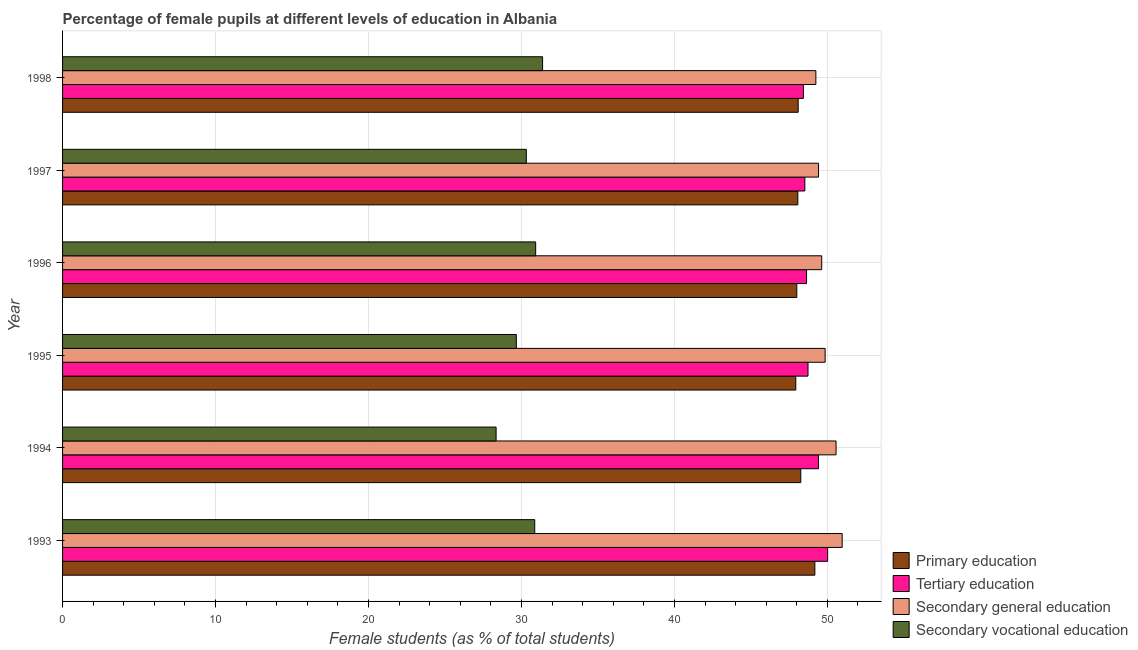How many bars are there on the 4th tick from the bottom?
Offer a terse response. 4. What is the percentage of female students in secondary vocational education in 1996?
Offer a terse response. 30.93. Across all years, what is the maximum percentage of female students in secondary education?
Offer a very short reply. 50.97. Across all years, what is the minimum percentage of female students in secondary education?
Make the answer very short. 49.25. In which year was the percentage of female students in primary education minimum?
Offer a very short reply. 1995. What is the total percentage of female students in tertiary education in the graph?
Provide a short and direct response. 293.76. What is the difference between the percentage of female students in tertiary education in 1993 and that in 1994?
Ensure brevity in your answer.  0.6. What is the difference between the percentage of female students in secondary vocational education in 1997 and the percentage of female students in tertiary education in 1995?
Your answer should be compact. -18.42. What is the average percentage of female students in primary education per year?
Your response must be concise. 48.26. In the year 1995, what is the difference between the percentage of female students in primary education and percentage of female students in secondary education?
Keep it short and to the point. -1.92. What is the ratio of the percentage of female students in secondary vocational education in 1994 to that in 1998?
Offer a terse response. 0.9. Is the difference between the percentage of female students in secondary education in 1993 and 1997 greater than the difference between the percentage of female students in secondary vocational education in 1993 and 1997?
Your answer should be compact. Yes. What is the difference between the highest and the second highest percentage of female students in tertiary education?
Offer a terse response. 0.6. What is the difference between the highest and the lowest percentage of female students in secondary vocational education?
Your answer should be very brief. 3.04. What does the 2nd bar from the top in 1998 represents?
Offer a very short reply. Secondary general education. What does the 4th bar from the bottom in 1997 represents?
Your answer should be compact. Secondary vocational education. Are all the bars in the graph horizontal?
Provide a succinct answer. Yes. How many years are there in the graph?
Keep it short and to the point. 6. Where does the legend appear in the graph?
Offer a terse response. Bottom right. How are the legend labels stacked?
Make the answer very short. Vertical. What is the title of the graph?
Offer a very short reply. Percentage of female pupils at different levels of education in Albania. Does "Taxes on goods and services" appear as one of the legend labels in the graph?
Your response must be concise. No. What is the label or title of the X-axis?
Keep it short and to the point. Female students (as % of total students). What is the Female students (as % of total students) in Primary education in 1993?
Provide a short and direct response. 49.18. What is the Female students (as % of total students) of Tertiary education in 1993?
Offer a very short reply. 50.02. What is the Female students (as % of total students) of Secondary general education in 1993?
Provide a short and direct response. 50.97. What is the Female students (as % of total students) in Secondary vocational education in 1993?
Offer a very short reply. 30.87. What is the Female students (as % of total students) in Primary education in 1994?
Keep it short and to the point. 48.26. What is the Female students (as % of total students) in Tertiary education in 1994?
Offer a terse response. 49.42. What is the Female students (as % of total students) in Secondary general education in 1994?
Make the answer very short. 50.57. What is the Female students (as % of total students) of Secondary vocational education in 1994?
Your response must be concise. 28.34. What is the Female students (as % of total students) of Primary education in 1995?
Provide a short and direct response. 47.93. What is the Female students (as % of total students) in Tertiary education in 1995?
Your response must be concise. 48.73. What is the Female students (as % of total students) of Secondary general education in 1995?
Your answer should be very brief. 49.85. What is the Female students (as % of total students) of Secondary vocational education in 1995?
Keep it short and to the point. 29.66. What is the Female students (as % of total students) of Primary education in 1996?
Your answer should be compact. 48. What is the Female students (as % of total students) in Tertiary education in 1996?
Offer a terse response. 48.64. What is the Female students (as % of total students) in Secondary general education in 1996?
Provide a short and direct response. 49.63. What is the Female students (as % of total students) in Secondary vocational education in 1996?
Your answer should be compact. 30.93. What is the Female students (as % of total students) in Primary education in 1997?
Give a very brief answer. 48.07. What is the Female students (as % of total students) of Tertiary education in 1997?
Offer a terse response. 48.53. What is the Female students (as % of total students) in Secondary general education in 1997?
Your answer should be compact. 49.42. What is the Female students (as % of total students) in Secondary vocational education in 1997?
Ensure brevity in your answer.  30.32. What is the Female students (as % of total students) in Primary education in 1998?
Provide a short and direct response. 48.09. What is the Female students (as % of total students) of Tertiary education in 1998?
Make the answer very short. 48.43. What is the Female students (as % of total students) in Secondary general education in 1998?
Your answer should be very brief. 49.25. What is the Female students (as % of total students) of Secondary vocational education in 1998?
Give a very brief answer. 31.38. Across all years, what is the maximum Female students (as % of total students) of Primary education?
Offer a very short reply. 49.18. Across all years, what is the maximum Female students (as % of total students) in Tertiary education?
Your response must be concise. 50.02. Across all years, what is the maximum Female students (as % of total students) in Secondary general education?
Make the answer very short. 50.97. Across all years, what is the maximum Female students (as % of total students) of Secondary vocational education?
Provide a succinct answer. 31.38. Across all years, what is the minimum Female students (as % of total students) in Primary education?
Make the answer very short. 47.93. Across all years, what is the minimum Female students (as % of total students) in Tertiary education?
Provide a succinct answer. 48.43. Across all years, what is the minimum Female students (as % of total students) in Secondary general education?
Your response must be concise. 49.25. Across all years, what is the minimum Female students (as % of total students) in Secondary vocational education?
Your answer should be very brief. 28.34. What is the total Female students (as % of total students) in Primary education in the graph?
Ensure brevity in your answer.  289.53. What is the total Female students (as % of total students) in Tertiary education in the graph?
Give a very brief answer. 293.76. What is the total Female students (as % of total students) of Secondary general education in the graph?
Make the answer very short. 299.68. What is the total Female students (as % of total students) in Secondary vocational education in the graph?
Your answer should be very brief. 181.5. What is the difference between the Female students (as % of total students) of Primary education in 1993 and that in 1994?
Your answer should be compact. 0.92. What is the difference between the Female students (as % of total students) in Tertiary education in 1993 and that in 1994?
Provide a short and direct response. 0.6. What is the difference between the Female students (as % of total students) in Secondary general education in 1993 and that in 1994?
Make the answer very short. 0.4. What is the difference between the Female students (as % of total students) in Secondary vocational education in 1993 and that in 1994?
Offer a terse response. 2.53. What is the difference between the Female students (as % of total students) in Primary education in 1993 and that in 1995?
Your answer should be compact. 1.25. What is the difference between the Female students (as % of total students) in Tertiary education in 1993 and that in 1995?
Your answer should be very brief. 1.28. What is the difference between the Female students (as % of total students) of Secondary general education in 1993 and that in 1995?
Provide a short and direct response. 1.11. What is the difference between the Female students (as % of total students) in Secondary vocational education in 1993 and that in 1995?
Offer a terse response. 1.2. What is the difference between the Female students (as % of total students) in Primary education in 1993 and that in 1996?
Provide a short and direct response. 1.18. What is the difference between the Female students (as % of total students) of Tertiary education in 1993 and that in 1996?
Offer a terse response. 1.38. What is the difference between the Female students (as % of total students) of Secondary general education in 1993 and that in 1996?
Your answer should be compact. 1.34. What is the difference between the Female students (as % of total students) of Secondary vocational education in 1993 and that in 1996?
Ensure brevity in your answer.  -0.06. What is the difference between the Female students (as % of total students) of Primary education in 1993 and that in 1997?
Give a very brief answer. 1.11. What is the difference between the Female students (as % of total students) in Tertiary education in 1993 and that in 1997?
Your answer should be compact. 1.49. What is the difference between the Female students (as % of total students) in Secondary general education in 1993 and that in 1997?
Provide a short and direct response. 1.54. What is the difference between the Female students (as % of total students) of Secondary vocational education in 1993 and that in 1997?
Your answer should be compact. 0.55. What is the difference between the Female students (as % of total students) in Primary education in 1993 and that in 1998?
Your response must be concise. 1.09. What is the difference between the Female students (as % of total students) of Tertiary education in 1993 and that in 1998?
Make the answer very short. 1.59. What is the difference between the Female students (as % of total students) of Secondary general education in 1993 and that in 1998?
Provide a short and direct response. 1.72. What is the difference between the Female students (as % of total students) in Secondary vocational education in 1993 and that in 1998?
Your response must be concise. -0.51. What is the difference between the Female students (as % of total students) of Primary education in 1994 and that in 1995?
Keep it short and to the point. 0.33. What is the difference between the Female students (as % of total students) of Tertiary education in 1994 and that in 1995?
Provide a short and direct response. 0.68. What is the difference between the Female students (as % of total students) in Secondary general education in 1994 and that in 1995?
Provide a succinct answer. 0.71. What is the difference between the Female students (as % of total students) of Secondary vocational education in 1994 and that in 1995?
Make the answer very short. -1.32. What is the difference between the Female students (as % of total students) of Primary education in 1994 and that in 1996?
Keep it short and to the point. 0.26. What is the difference between the Female students (as % of total students) of Tertiary education in 1994 and that in 1996?
Offer a terse response. 0.78. What is the difference between the Female students (as % of total students) of Secondary general education in 1994 and that in 1996?
Provide a short and direct response. 0.94. What is the difference between the Female students (as % of total students) of Secondary vocational education in 1994 and that in 1996?
Your response must be concise. -2.59. What is the difference between the Female students (as % of total students) in Primary education in 1994 and that in 1997?
Ensure brevity in your answer.  0.19. What is the difference between the Female students (as % of total students) in Tertiary education in 1994 and that in 1997?
Provide a short and direct response. 0.89. What is the difference between the Female students (as % of total students) in Secondary general education in 1994 and that in 1997?
Ensure brevity in your answer.  1.15. What is the difference between the Female students (as % of total students) of Secondary vocational education in 1994 and that in 1997?
Offer a very short reply. -1.97. What is the difference between the Female students (as % of total students) of Primary education in 1994 and that in 1998?
Your answer should be compact. 0.17. What is the difference between the Female students (as % of total students) of Secondary general education in 1994 and that in 1998?
Your response must be concise. 1.32. What is the difference between the Female students (as % of total students) in Secondary vocational education in 1994 and that in 1998?
Offer a terse response. -3.04. What is the difference between the Female students (as % of total students) of Primary education in 1995 and that in 1996?
Offer a terse response. -0.07. What is the difference between the Female students (as % of total students) in Tertiary education in 1995 and that in 1996?
Your answer should be very brief. 0.1. What is the difference between the Female students (as % of total students) in Secondary general education in 1995 and that in 1996?
Provide a short and direct response. 0.22. What is the difference between the Female students (as % of total students) in Secondary vocational education in 1995 and that in 1996?
Provide a short and direct response. -1.27. What is the difference between the Female students (as % of total students) of Primary education in 1995 and that in 1997?
Keep it short and to the point. -0.13. What is the difference between the Female students (as % of total students) of Tertiary education in 1995 and that in 1997?
Provide a short and direct response. 0.21. What is the difference between the Female students (as % of total students) of Secondary general education in 1995 and that in 1997?
Offer a very short reply. 0.43. What is the difference between the Female students (as % of total students) in Secondary vocational education in 1995 and that in 1997?
Offer a very short reply. -0.65. What is the difference between the Female students (as % of total students) of Primary education in 1995 and that in 1998?
Offer a very short reply. -0.16. What is the difference between the Female students (as % of total students) in Tertiary education in 1995 and that in 1998?
Give a very brief answer. 0.3. What is the difference between the Female students (as % of total students) in Secondary general education in 1995 and that in 1998?
Keep it short and to the point. 0.61. What is the difference between the Female students (as % of total students) in Secondary vocational education in 1995 and that in 1998?
Your answer should be compact. -1.72. What is the difference between the Female students (as % of total students) in Primary education in 1996 and that in 1997?
Make the answer very short. -0.07. What is the difference between the Female students (as % of total students) of Tertiary education in 1996 and that in 1997?
Your answer should be compact. 0.11. What is the difference between the Female students (as % of total students) in Secondary general education in 1996 and that in 1997?
Provide a short and direct response. 0.21. What is the difference between the Female students (as % of total students) of Secondary vocational education in 1996 and that in 1997?
Make the answer very short. 0.61. What is the difference between the Female students (as % of total students) of Primary education in 1996 and that in 1998?
Your answer should be very brief. -0.09. What is the difference between the Female students (as % of total students) of Tertiary education in 1996 and that in 1998?
Provide a short and direct response. 0.21. What is the difference between the Female students (as % of total students) in Secondary general education in 1996 and that in 1998?
Make the answer very short. 0.38. What is the difference between the Female students (as % of total students) of Secondary vocational education in 1996 and that in 1998?
Your answer should be compact. -0.45. What is the difference between the Female students (as % of total students) in Primary education in 1997 and that in 1998?
Your answer should be compact. -0.02. What is the difference between the Female students (as % of total students) in Tertiary education in 1997 and that in 1998?
Offer a terse response. 0.1. What is the difference between the Female students (as % of total students) in Secondary general education in 1997 and that in 1998?
Ensure brevity in your answer.  0.18. What is the difference between the Female students (as % of total students) of Secondary vocational education in 1997 and that in 1998?
Offer a very short reply. -1.06. What is the difference between the Female students (as % of total students) of Primary education in 1993 and the Female students (as % of total students) of Tertiary education in 1994?
Offer a very short reply. -0.23. What is the difference between the Female students (as % of total students) in Primary education in 1993 and the Female students (as % of total students) in Secondary general education in 1994?
Give a very brief answer. -1.39. What is the difference between the Female students (as % of total students) of Primary education in 1993 and the Female students (as % of total students) of Secondary vocational education in 1994?
Provide a succinct answer. 20.84. What is the difference between the Female students (as % of total students) in Tertiary education in 1993 and the Female students (as % of total students) in Secondary general education in 1994?
Provide a short and direct response. -0.55. What is the difference between the Female students (as % of total students) in Tertiary education in 1993 and the Female students (as % of total students) in Secondary vocational education in 1994?
Give a very brief answer. 21.67. What is the difference between the Female students (as % of total students) in Secondary general education in 1993 and the Female students (as % of total students) in Secondary vocational education in 1994?
Your response must be concise. 22.62. What is the difference between the Female students (as % of total students) in Primary education in 1993 and the Female students (as % of total students) in Tertiary education in 1995?
Provide a short and direct response. 0.45. What is the difference between the Female students (as % of total students) of Primary education in 1993 and the Female students (as % of total students) of Secondary general education in 1995?
Give a very brief answer. -0.67. What is the difference between the Female students (as % of total students) in Primary education in 1993 and the Female students (as % of total students) in Secondary vocational education in 1995?
Your answer should be compact. 19.52. What is the difference between the Female students (as % of total students) of Tertiary education in 1993 and the Female students (as % of total students) of Secondary general education in 1995?
Offer a very short reply. 0.16. What is the difference between the Female students (as % of total students) of Tertiary education in 1993 and the Female students (as % of total students) of Secondary vocational education in 1995?
Give a very brief answer. 20.35. What is the difference between the Female students (as % of total students) of Secondary general education in 1993 and the Female students (as % of total students) of Secondary vocational education in 1995?
Your answer should be very brief. 21.3. What is the difference between the Female students (as % of total students) of Primary education in 1993 and the Female students (as % of total students) of Tertiary education in 1996?
Make the answer very short. 0.54. What is the difference between the Female students (as % of total students) of Primary education in 1993 and the Female students (as % of total students) of Secondary general education in 1996?
Offer a very short reply. -0.45. What is the difference between the Female students (as % of total students) in Primary education in 1993 and the Female students (as % of total students) in Secondary vocational education in 1996?
Offer a terse response. 18.25. What is the difference between the Female students (as % of total students) in Tertiary education in 1993 and the Female students (as % of total students) in Secondary general education in 1996?
Keep it short and to the point. 0.39. What is the difference between the Female students (as % of total students) of Tertiary education in 1993 and the Female students (as % of total students) of Secondary vocational education in 1996?
Make the answer very short. 19.09. What is the difference between the Female students (as % of total students) of Secondary general education in 1993 and the Female students (as % of total students) of Secondary vocational education in 1996?
Your response must be concise. 20.04. What is the difference between the Female students (as % of total students) in Primary education in 1993 and the Female students (as % of total students) in Tertiary education in 1997?
Provide a succinct answer. 0.65. What is the difference between the Female students (as % of total students) of Primary education in 1993 and the Female students (as % of total students) of Secondary general education in 1997?
Offer a terse response. -0.24. What is the difference between the Female students (as % of total students) of Primary education in 1993 and the Female students (as % of total students) of Secondary vocational education in 1997?
Your answer should be compact. 18.86. What is the difference between the Female students (as % of total students) of Tertiary education in 1993 and the Female students (as % of total students) of Secondary general education in 1997?
Make the answer very short. 0.59. What is the difference between the Female students (as % of total students) in Tertiary education in 1993 and the Female students (as % of total students) in Secondary vocational education in 1997?
Provide a short and direct response. 19.7. What is the difference between the Female students (as % of total students) of Secondary general education in 1993 and the Female students (as % of total students) of Secondary vocational education in 1997?
Your response must be concise. 20.65. What is the difference between the Female students (as % of total students) of Primary education in 1993 and the Female students (as % of total students) of Tertiary education in 1998?
Your response must be concise. 0.75. What is the difference between the Female students (as % of total students) in Primary education in 1993 and the Female students (as % of total students) in Secondary general education in 1998?
Your answer should be compact. -0.06. What is the difference between the Female students (as % of total students) in Primary education in 1993 and the Female students (as % of total students) in Secondary vocational education in 1998?
Give a very brief answer. 17.8. What is the difference between the Female students (as % of total students) in Tertiary education in 1993 and the Female students (as % of total students) in Secondary general education in 1998?
Offer a very short reply. 0.77. What is the difference between the Female students (as % of total students) in Tertiary education in 1993 and the Female students (as % of total students) in Secondary vocational education in 1998?
Provide a succinct answer. 18.63. What is the difference between the Female students (as % of total students) in Secondary general education in 1993 and the Female students (as % of total students) in Secondary vocational education in 1998?
Give a very brief answer. 19.58. What is the difference between the Female students (as % of total students) of Primary education in 1994 and the Female students (as % of total students) of Tertiary education in 1995?
Ensure brevity in your answer.  -0.47. What is the difference between the Female students (as % of total students) in Primary education in 1994 and the Female students (as % of total students) in Secondary general education in 1995?
Your answer should be very brief. -1.59. What is the difference between the Female students (as % of total students) in Primary education in 1994 and the Female students (as % of total students) in Secondary vocational education in 1995?
Keep it short and to the point. 18.6. What is the difference between the Female students (as % of total students) in Tertiary education in 1994 and the Female students (as % of total students) in Secondary general education in 1995?
Your answer should be compact. -0.44. What is the difference between the Female students (as % of total students) of Tertiary education in 1994 and the Female students (as % of total students) of Secondary vocational education in 1995?
Your answer should be compact. 19.75. What is the difference between the Female students (as % of total students) in Secondary general education in 1994 and the Female students (as % of total students) in Secondary vocational education in 1995?
Your answer should be very brief. 20.9. What is the difference between the Female students (as % of total students) in Primary education in 1994 and the Female students (as % of total students) in Tertiary education in 1996?
Provide a short and direct response. -0.38. What is the difference between the Female students (as % of total students) in Primary education in 1994 and the Female students (as % of total students) in Secondary general education in 1996?
Provide a succinct answer. -1.37. What is the difference between the Female students (as % of total students) in Primary education in 1994 and the Female students (as % of total students) in Secondary vocational education in 1996?
Offer a terse response. 17.33. What is the difference between the Female students (as % of total students) in Tertiary education in 1994 and the Female students (as % of total students) in Secondary general education in 1996?
Give a very brief answer. -0.21. What is the difference between the Female students (as % of total students) of Tertiary education in 1994 and the Female students (as % of total students) of Secondary vocational education in 1996?
Your answer should be compact. 18.49. What is the difference between the Female students (as % of total students) in Secondary general education in 1994 and the Female students (as % of total students) in Secondary vocational education in 1996?
Your response must be concise. 19.64. What is the difference between the Female students (as % of total students) in Primary education in 1994 and the Female students (as % of total students) in Tertiary education in 1997?
Offer a terse response. -0.27. What is the difference between the Female students (as % of total students) of Primary education in 1994 and the Female students (as % of total students) of Secondary general education in 1997?
Ensure brevity in your answer.  -1.16. What is the difference between the Female students (as % of total students) in Primary education in 1994 and the Female students (as % of total students) in Secondary vocational education in 1997?
Give a very brief answer. 17.94. What is the difference between the Female students (as % of total students) in Tertiary education in 1994 and the Female students (as % of total students) in Secondary general education in 1997?
Make the answer very short. -0.01. What is the difference between the Female students (as % of total students) of Tertiary education in 1994 and the Female students (as % of total students) of Secondary vocational education in 1997?
Offer a terse response. 19.1. What is the difference between the Female students (as % of total students) in Secondary general education in 1994 and the Female students (as % of total students) in Secondary vocational education in 1997?
Provide a short and direct response. 20.25. What is the difference between the Female students (as % of total students) in Primary education in 1994 and the Female students (as % of total students) in Tertiary education in 1998?
Ensure brevity in your answer.  -0.17. What is the difference between the Female students (as % of total students) in Primary education in 1994 and the Female students (as % of total students) in Secondary general education in 1998?
Keep it short and to the point. -0.99. What is the difference between the Female students (as % of total students) in Primary education in 1994 and the Female students (as % of total students) in Secondary vocational education in 1998?
Offer a terse response. 16.88. What is the difference between the Female students (as % of total students) in Tertiary education in 1994 and the Female students (as % of total students) in Secondary general education in 1998?
Keep it short and to the point. 0.17. What is the difference between the Female students (as % of total students) in Tertiary education in 1994 and the Female students (as % of total students) in Secondary vocational education in 1998?
Your answer should be very brief. 18.03. What is the difference between the Female students (as % of total students) in Secondary general education in 1994 and the Female students (as % of total students) in Secondary vocational education in 1998?
Your answer should be compact. 19.19. What is the difference between the Female students (as % of total students) in Primary education in 1995 and the Female students (as % of total students) in Tertiary education in 1996?
Provide a succinct answer. -0.7. What is the difference between the Female students (as % of total students) of Primary education in 1995 and the Female students (as % of total students) of Secondary general education in 1996?
Ensure brevity in your answer.  -1.69. What is the difference between the Female students (as % of total students) in Primary education in 1995 and the Female students (as % of total students) in Secondary vocational education in 1996?
Give a very brief answer. 17. What is the difference between the Female students (as % of total students) in Tertiary education in 1995 and the Female students (as % of total students) in Secondary general education in 1996?
Your answer should be compact. -0.9. What is the difference between the Female students (as % of total students) in Tertiary education in 1995 and the Female students (as % of total students) in Secondary vocational education in 1996?
Give a very brief answer. 17.8. What is the difference between the Female students (as % of total students) of Secondary general education in 1995 and the Female students (as % of total students) of Secondary vocational education in 1996?
Ensure brevity in your answer.  18.92. What is the difference between the Female students (as % of total students) of Primary education in 1995 and the Female students (as % of total students) of Tertiary education in 1997?
Offer a very short reply. -0.59. What is the difference between the Female students (as % of total students) of Primary education in 1995 and the Female students (as % of total students) of Secondary general education in 1997?
Your answer should be compact. -1.49. What is the difference between the Female students (as % of total students) in Primary education in 1995 and the Female students (as % of total students) in Secondary vocational education in 1997?
Keep it short and to the point. 17.62. What is the difference between the Female students (as % of total students) in Tertiary education in 1995 and the Female students (as % of total students) in Secondary general education in 1997?
Provide a succinct answer. -0.69. What is the difference between the Female students (as % of total students) of Tertiary education in 1995 and the Female students (as % of total students) of Secondary vocational education in 1997?
Offer a very short reply. 18.42. What is the difference between the Female students (as % of total students) of Secondary general education in 1995 and the Female students (as % of total students) of Secondary vocational education in 1997?
Your answer should be very brief. 19.54. What is the difference between the Female students (as % of total students) in Primary education in 1995 and the Female students (as % of total students) in Tertiary education in 1998?
Your response must be concise. -0.5. What is the difference between the Female students (as % of total students) in Primary education in 1995 and the Female students (as % of total students) in Secondary general education in 1998?
Keep it short and to the point. -1.31. What is the difference between the Female students (as % of total students) of Primary education in 1995 and the Female students (as % of total students) of Secondary vocational education in 1998?
Your response must be concise. 16.55. What is the difference between the Female students (as % of total students) of Tertiary education in 1995 and the Female students (as % of total students) of Secondary general education in 1998?
Give a very brief answer. -0.51. What is the difference between the Female students (as % of total students) in Tertiary education in 1995 and the Female students (as % of total students) in Secondary vocational education in 1998?
Make the answer very short. 17.35. What is the difference between the Female students (as % of total students) of Secondary general education in 1995 and the Female students (as % of total students) of Secondary vocational education in 1998?
Provide a succinct answer. 18.47. What is the difference between the Female students (as % of total students) of Primary education in 1996 and the Female students (as % of total students) of Tertiary education in 1997?
Offer a terse response. -0.53. What is the difference between the Female students (as % of total students) in Primary education in 1996 and the Female students (as % of total students) in Secondary general education in 1997?
Give a very brief answer. -1.42. What is the difference between the Female students (as % of total students) in Primary education in 1996 and the Female students (as % of total students) in Secondary vocational education in 1997?
Make the answer very short. 17.68. What is the difference between the Female students (as % of total students) in Tertiary education in 1996 and the Female students (as % of total students) in Secondary general education in 1997?
Provide a short and direct response. -0.78. What is the difference between the Female students (as % of total students) in Tertiary education in 1996 and the Female students (as % of total students) in Secondary vocational education in 1997?
Provide a short and direct response. 18.32. What is the difference between the Female students (as % of total students) of Secondary general education in 1996 and the Female students (as % of total students) of Secondary vocational education in 1997?
Your answer should be compact. 19.31. What is the difference between the Female students (as % of total students) of Primary education in 1996 and the Female students (as % of total students) of Tertiary education in 1998?
Provide a succinct answer. -0.43. What is the difference between the Female students (as % of total students) in Primary education in 1996 and the Female students (as % of total students) in Secondary general education in 1998?
Give a very brief answer. -1.24. What is the difference between the Female students (as % of total students) of Primary education in 1996 and the Female students (as % of total students) of Secondary vocational education in 1998?
Offer a terse response. 16.62. What is the difference between the Female students (as % of total students) of Tertiary education in 1996 and the Female students (as % of total students) of Secondary general education in 1998?
Your response must be concise. -0.61. What is the difference between the Female students (as % of total students) in Tertiary education in 1996 and the Female students (as % of total students) in Secondary vocational education in 1998?
Give a very brief answer. 17.26. What is the difference between the Female students (as % of total students) in Secondary general education in 1996 and the Female students (as % of total students) in Secondary vocational education in 1998?
Make the answer very short. 18.25. What is the difference between the Female students (as % of total students) of Primary education in 1997 and the Female students (as % of total students) of Tertiary education in 1998?
Your answer should be very brief. -0.36. What is the difference between the Female students (as % of total students) of Primary education in 1997 and the Female students (as % of total students) of Secondary general education in 1998?
Provide a short and direct response. -1.18. What is the difference between the Female students (as % of total students) of Primary education in 1997 and the Female students (as % of total students) of Secondary vocational education in 1998?
Your answer should be compact. 16.69. What is the difference between the Female students (as % of total students) in Tertiary education in 1997 and the Female students (as % of total students) in Secondary general education in 1998?
Provide a short and direct response. -0.72. What is the difference between the Female students (as % of total students) of Tertiary education in 1997 and the Female students (as % of total students) of Secondary vocational education in 1998?
Offer a very short reply. 17.14. What is the difference between the Female students (as % of total students) in Secondary general education in 1997 and the Female students (as % of total students) in Secondary vocational education in 1998?
Give a very brief answer. 18.04. What is the average Female students (as % of total students) in Primary education per year?
Provide a short and direct response. 48.26. What is the average Female students (as % of total students) in Tertiary education per year?
Ensure brevity in your answer.  48.96. What is the average Female students (as % of total students) of Secondary general education per year?
Give a very brief answer. 49.95. What is the average Female students (as % of total students) of Secondary vocational education per year?
Your answer should be very brief. 30.25. In the year 1993, what is the difference between the Female students (as % of total students) in Primary education and Female students (as % of total students) in Tertiary education?
Keep it short and to the point. -0.84. In the year 1993, what is the difference between the Female students (as % of total students) in Primary education and Female students (as % of total students) in Secondary general education?
Make the answer very short. -1.79. In the year 1993, what is the difference between the Female students (as % of total students) in Primary education and Female students (as % of total students) in Secondary vocational education?
Provide a short and direct response. 18.31. In the year 1993, what is the difference between the Female students (as % of total students) of Tertiary education and Female students (as % of total students) of Secondary general education?
Offer a very short reply. -0.95. In the year 1993, what is the difference between the Female students (as % of total students) in Tertiary education and Female students (as % of total students) in Secondary vocational education?
Your answer should be very brief. 19.15. In the year 1993, what is the difference between the Female students (as % of total students) of Secondary general education and Female students (as % of total students) of Secondary vocational education?
Provide a short and direct response. 20.1. In the year 1994, what is the difference between the Female students (as % of total students) of Primary education and Female students (as % of total students) of Tertiary education?
Give a very brief answer. -1.16. In the year 1994, what is the difference between the Female students (as % of total students) in Primary education and Female students (as % of total students) in Secondary general education?
Offer a terse response. -2.31. In the year 1994, what is the difference between the Female students (as % of total students) of Primary education and Female students (as % of total students) of Secondary vocational education?
Your answer should be compact. 19.92. In the year 1994, what is the difference between the Female students (as % of total students) in Tertiary education and Female students (as % of total students) in Secondary general education?
Provide a succinct answer. -1.15. In the year 1994, what is the difference between the Female students (as % of total students) in Tertiary education and Female students (as % of total students) in Secondary vocational education?
Keep it short and to the point. 21.07. In the year 1994, what is the difference between the Female students (as % of total students) of Secondary general education and Female students (as % of total students) of Secondary vocational education?
Make the answer very short. 22.22. In the year 1995, what is the difference between the Female students (as % of total students) of Primary education and Female students (as % of total students) of Tertiary education?
Your answer should be compact. -0.8. In the year 1995, what is the difference between the Female students (as % of total students) in Primary education and Female students (as % of total students) in Secondary general education?
Offer a very short reply. -1.92. In the year 1995, what is the difference between the Female students (as % of total students) of Primary education and Female students (as % of total students) of Secondary vocational education?
Give a very brief answer. 18.27. In the year 1995, what is the difference between the Female students (as % of total students) of Tertiary education and Female students (as % of total students) of Secondary general education?
Give a very brief answer. -1.12. In the year 1995, what is the difference between the Female students (as % of total students) in Tertiary education and Female students (as % of total students) in Secondary vocational education?
Keep it short and to the point. 19.07. In the year 1995, what is the difference between the Female students (as % of total students) of Secondary general education and Female students (as % of total students) of Secondary vocational education?
Your answer should be compact. 20.19. In the year 1996, what is the difference between the Female students (as % of total students) of Primary education and Female students (as % of total students) of Tertiary education?
Give a very brief answer. -0.64. In the year 1996, what is the difference between the Female students (as % of total students) of Primary education and Female students (as % of total students) of Secondary general education?
Your answer should be very brief. -1.63. In the year 1996, what is the difference between the Female students (as % of total students) in Primary education and Female students (as % of total students) in Secondary vocational education?
Your response must be concise. 17.07. In the year 1996, what is the difference between the Female students (as % of total students) of Tertiary education and Female students (as % of total students) of Secondary general education?
Ensure brevity in your answer.  -0.99. In the year 1996, what is the difference between the Female students (as % of total students) in Tertiary education and Female students (as % of total students) in Secondary vocational education?
Give a very brief answer. 17.71. In the year 1996, what is the difference between the Female students (as % of total students) in Secondary general education and Female students (as % of total students) in Secondary vocational education?
Your answer should be very brief. 18.7. In the year 1997, what is the difference between the Female students (as % of total students) in Primary education and Female students (as % of total students) in Tertiary education?
Make the answer very short. -0.46. In the year 1997, what is the difference between the Female students (as % of total students) in Primary education and Female students (as % of total students) in Secondary general education?
Offer a terse response. -1.35. In the year 1997, what is the difference between the Female students (as % of total students) of Primary education and Female students (as % of total students) of Secondary vocational education?
Your response must be concise. 17.75. In the year 1997, what is the difference between the Female students (as % of total students) in Tertiary education and Female students (as % of total students) in Secondary general education?
Your answer should be very brief. -0.89. In the year 1997, what is the difference between the Female students (as % of total students) of Tertiary education and Female students (as % of total students) of Secondary vocational education?
Offer a very short reply. 18.21. In the year 1997, what is the difference between the Female students (as % of total students) in Secondary general education and Female students (as % of total students) in Secondary vocational education?
Keep it short and to the point. 19.1. In the year 1998, what is the difference between the Female students (as % of total students) of Primary education and Female students (as % of total students) of Tertiary education?
Offer a terse response. -0.34. In the year 1998, what is the difference between the Female students (as % of total students) in Primary education and Female students (as % of total students) in Secondary general education?
Keep it short and to the point. -1.16. In the year 1998, what is the difference between the Female students (as % of total students) of Primary education and Female students (as % of total students) of Secondary vocational education?
Provide a succinct answer. 16.71. In the year 1998, what is the difference between the Female students (as % of total students) of Tertiary education and Female students (as % of total students) of Secondary general education?
Offer a terse response. -0.82. In the year 1998, what is the difference between the Female students (as % of total students) in Tertiary education and Female students (as % of total students) in Secondary vocational education?
Provide a succinct answer. 17.05. In the year 1998, what is the difference between the Female students (as % of total students) of Secondary general education and Female students (as % of total students) of Secondary vocational education?
Keep it short and to the point. 17.86. What is the ratio of the Female students (as % of total students) of Primary education in 1993 to that in 1994?
Give a very brief answer. 1.02. What is the ratio of the Female students (as % of total students) in Tertiary education in 1993 to that in 1994?
Your response must be concise. 1.01. What is the ratio of the Female students (as % of total students) of Secondary general education in 1993 to that in 1994?
Provide a short and direct response. 1.01. What is the ratio of the Female students (as % of total students) in Secondary vocational education in 1993 to that in 1994?
Provide a short and direct response. 1.09. What is the ratio of the Female students (as % of total students) in Primary education in 1993 to that in 1995?
Ensure brevity in your answer.  1.03. What is the ratio of the Female students (as % of total students) in Tertiary education in 1993 to that in 1995?
Ensure brevity in your answer.  1.03. What is the ratio of the Female students (as % of total students) in Secondary general education in 1993 to that in 1995?
Your answer should be very brief. 1.02. What is the ratio of the Female students (as % of total students) in Secondary vocational education in 1993 to that in 1995?
Ensure brevity in your answer.  1.04. What is the ratio of the Female students (as % of total students) in Primary education in 1993 to that in 1996?
Make the answer very short. 1.02. What is the ratio of the Female students (as % of total students) of Tertiary education in 1993 to that in 1996?
Provide a succinct answer. 1.03. What is the ratio of the Female students (as % of total students) in Secondary general education in 1993 to that in 1996?
Give a very brief answer. 1.03. What is the ratio of the Female students (as % of total students) of Secondary vocational education in 1993 to that in 1996?
Make the answer very short. 1. What is the ratio of the Female students (as % of total students) in Primary education in 1993 to that in 1997?
Provide a succinct answer. 1.02. What is the ratio of the Female students (as % of total students) in Tertiary education in 1993 to that in 1997?
Provide a short and direct response. 1.03. What is the ratio of the Female students (as % of total students) of Secondary general education in 1993 to that in 1997?
Offer a very short reply. 1.03. What is the ratio of the Female students (as % of total students) in Secondary vocational education in 1993 to that in 1997?
Give a very brief answer. 1.02. What is the ratio of the Female students (as % of total students) in Primary education in 1993 to that in 1998?
Offer a terse response. 1.02. What is the ratio of the Female students (as % of total students) in Tertiary education in 1993 to that in 1998?
Ensure brevity in your answer.  1.03. What is the ratio of the Female students (as % of total students) of Secondary general education in 1993 to that in 1998?
Ensure brevity in your answer.  1.03. What is the ratio of the Female students (as % of total students) in Secondary vocational education in 1993 to that in 1998?
Provide a short and direct response. 0.98. What is the ratio of the Female students (as % of total students) in Primary education in 1994 to that in 1995?
Your answer should be compact. 1.01. What is the ratio of the Female students (as % of total students) of Secondary general education in 1994 to that in 1995?
Ensure brevity in your answer.  1.01. What is the ratio of the Female students (as % of total students) of Secondary vocational education in 1994 to that in 1995?
Offer a very short reply. 0.96. What is the ratio of the Female students (as % of total students) of Primary education in 1994 to that in 1996?
Your response must be concise. 1.01. What is the ratio of the Female students (as % of total students) in Secondary general education in 1994 to that in 1996?
Your answer should be compact. 1.02. What is the ratio of the Female students (as % of total students) of Secondary vocational education in 1994 to that in 1996?
Keep it short and to the point. 0.92. What is the ratio of the Female students (as % of total students) in Tertiary education in 1994 to that in 1997?
Provide a short and direct response. 1.02. What is the ratio of the Female students (as % of total students) of Secondary general education in 1994 to that in 1997?
Offer a terse response. 1.02. What is the ratio of the Female students (as % of total students) of Secondary vocational education in 1994 to that in 1997?
Ensure brevity in your answer.  0.93. What is the ratio of the Female students (as % of total students) in Primary education in 1994 to that in 1998?
Your response must be concise. 1. What is the ratio of the Female students (as % of total students) of Tertiary education in 1994 to that in 1998?
Make the answer very short. 1.02. What is the ratio of the Female students (as % of total students) of Secondary general education in 1994 to that in 1998?
Keep it short and to the point. 1.03. What is the ratio of the Female students (as % of total students) of Secondary vocational education in 1994 to that in 1998?
Your answer should be compact. 0.9. What is the ratio of the Female students (as % of total students) of Secondary general education in 1995 to that in 1996?
Offer a terse response. 1. What is the ratio of the Female students (as % of total students) of Secondary vocational education in 1995 to that in 1996?
Provide a succinct answer. 0.96. What is the ratio of the Female students (as % of total students) in Primary education in 1995 to that in 1997?
Keep it short and to the point. 1. What is the ratio of the Female students (as % of total students) in Secondary general education in 1995 to that in 1997?
Your answer should be compact. 1.01. What is the ratio of the Female students (as % of total students) in Secondary vocational education in 1995 to that in 1997?
Offer a very short reply. 0.98. What is the ratio of the Female students (as % of total students) in Primary education in 1995 to that in 1998?
Offer a terse response. 1. What is the ratio of the Female students (as % of total students) of Secondary general education in 1995 to that in 1998?
Offer a very short reply. 1.01. What is the ratio of the Female students (as % of total students) in Secondary vocational education in 1995 to that in 1998?
Provide a succinct answer. 0.95. What is the ratio of the Female students (as % of total students) in Primary education in 1996 to that in 1997?
Offer a terse response. 1. What is the ratio of the Female students (as % of total students) in Tertiary education in 1996 to that in 1997?
Give a very brief answer. 1. What is the ratio of the Female students (as % of total students) of Secondary general education in 1996 to that in 1997?
Provide a succinct answer. 1. What is the ratio of the Female students (as % of total students) of Secondary vocational education in 1996 to that in 1997?
Provide a short and direct response. 1.02. What is the ratio of the Female students (as % of total students) of Secondary vocational education in 1996 to that in 1998?
Ensure brevity in your answer.  0.99. What is the ratio of the Female students (as % of total students) of Secondary general education in 1997 to that in 1998?
Your response must be concise. 1. What is the ratio of the Female students (as % of total students) of Secondary vocational education in 1997 to that in 1998?
Provide a short and direct response. 0.97. What is the difference between the highest and the second highest Female students (as % of total students) in Primary education?
Offer a terse response. 0.92. What is the difference between the highest and the second highest Female students (as % of total students) in Tertiary education?
Keep it short and to the point. 0.6. What is the difference between the highest and the second highest Female students (as % of total students) of Secondary general education?
Give a very brief answer. 0.4. What is the difference between the highest and the second highest Female students (as % of total students) in Secondary vocational education?
Offer a very short reply. 0.45. What is the difference between the highest and the lowest Female students (as % of total students) of Primary education?
Your answer should be very brief. 1.25. What is the difference between the highest and the lowest Female students (as % of total students) in Tertiary education?
Offer a terse response. 1.59. What is the difference between the highest and the lowest Female students (as % of total students) of Secondary general education?
Your answer should be very brief. 1.72. What is the difference between the highest and the lowest Female students (as % of total students) in Secondary vocational education?
Offer a very short reply. 3.04. 